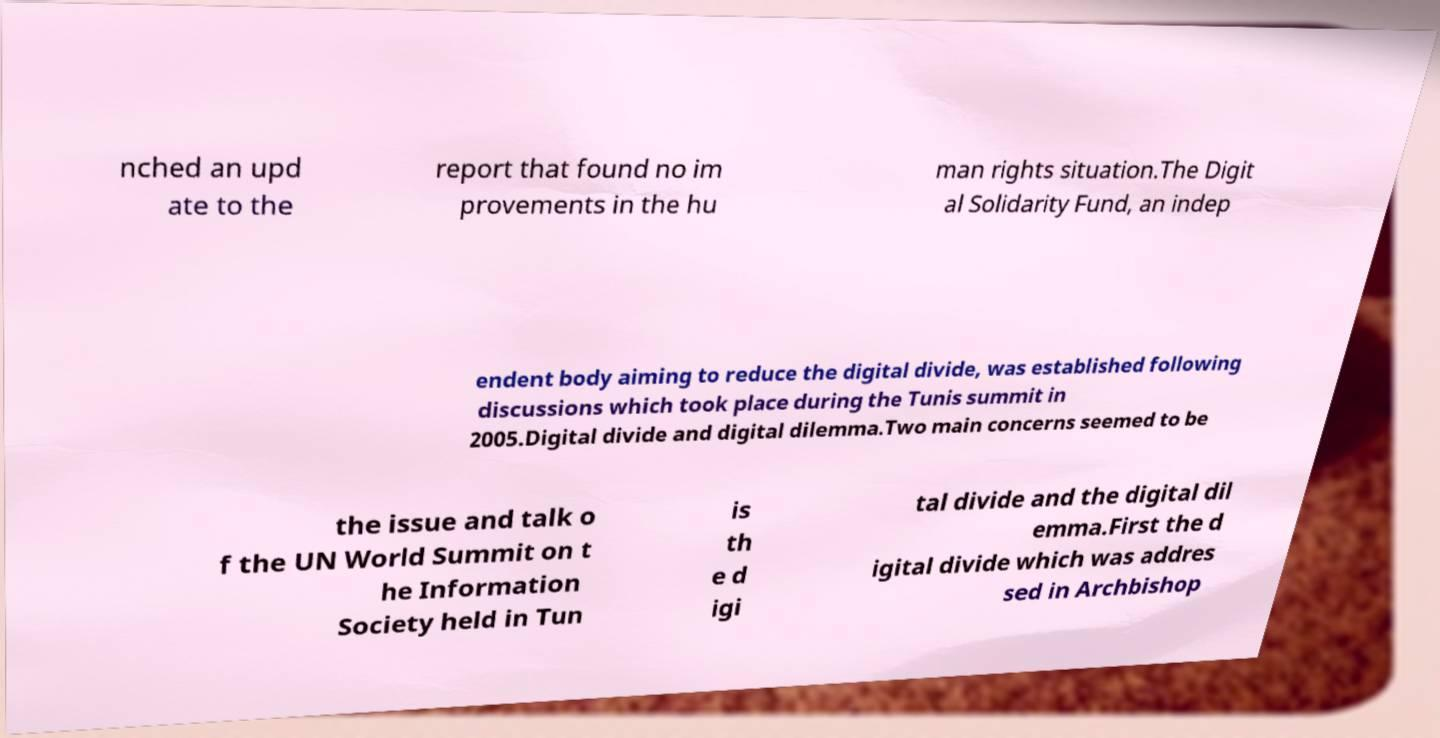Could you extract and type out the text from this image? nched an upd ate to the report that found no im provements in the hu man rights situation.The Digit al Solidarity Fund, an indep endent body aiming to reduce the digital divide, was established following discussions which took place during the Tunis summit in 2005.Digital divide and digital dilemma.Two main concerns seemed to be the issue and talk o f the UN World Summit on t he Information Society held in Tun is th e d igi tal divide and the digital dil emma.First the d igital divide which was addres sed in Archbishop 